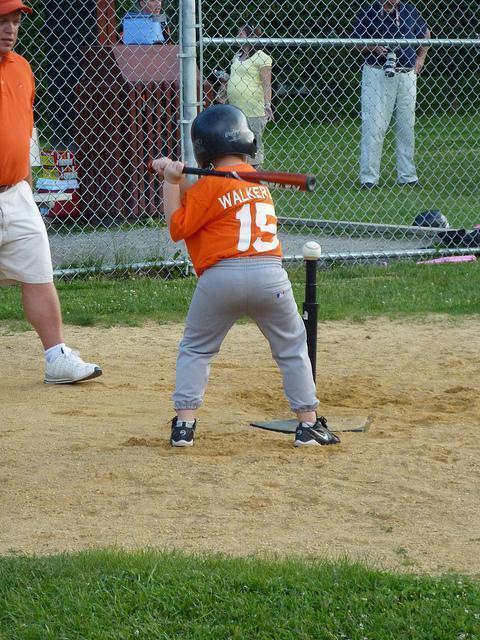What is this kid playing in?
Indicate the correct response by choosing from the four available options to answer the question.
Options: Football, little guys, little league, gone. Little league. 